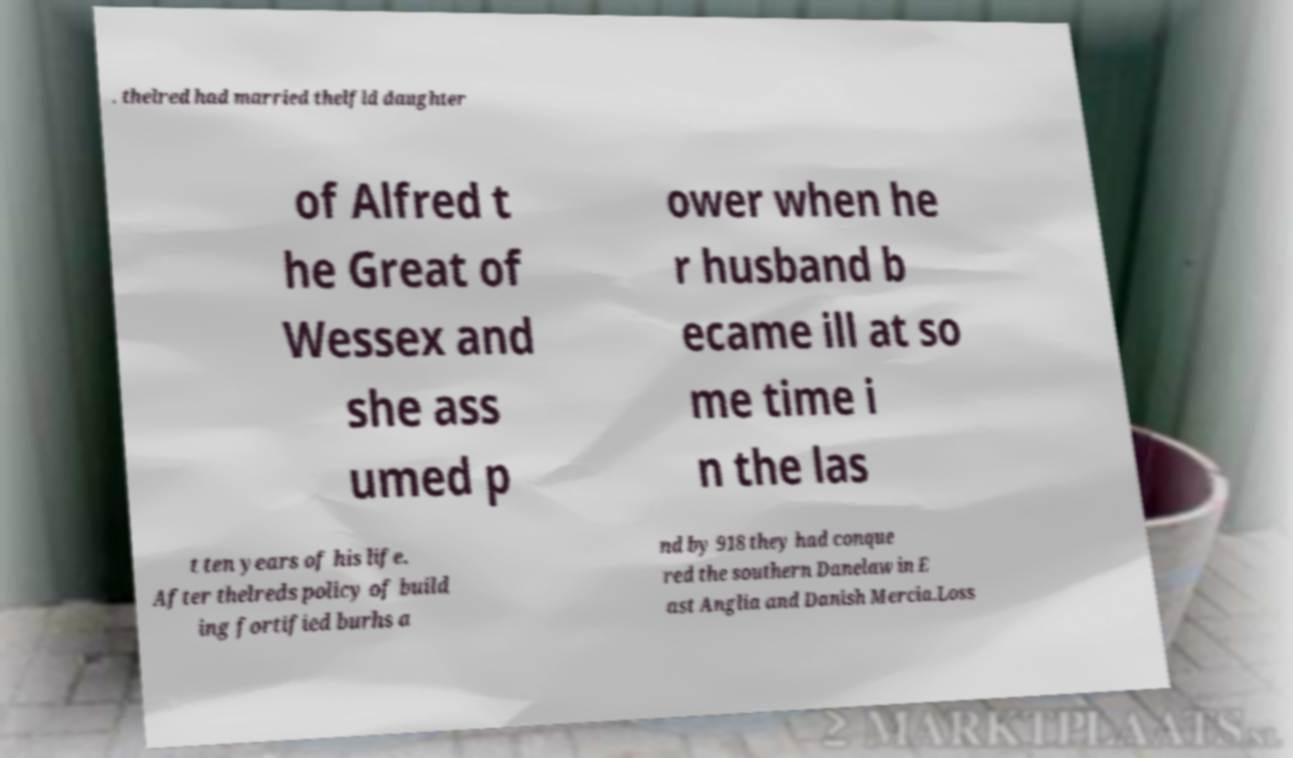For documentation purposes, I need the text within this image transcribed. Could you provide that? . thelred had married thelfld daughter of Alfred t he Great of Wessex and she ass umed p ower when he r husband b ecame ill at so me time i n the las t ten years of his life. After thelreds policy of build ing fortified burhs a nd by 918 they had conque red the southern Danelaw in E ast Anglia and Danish Mercia.Loss 